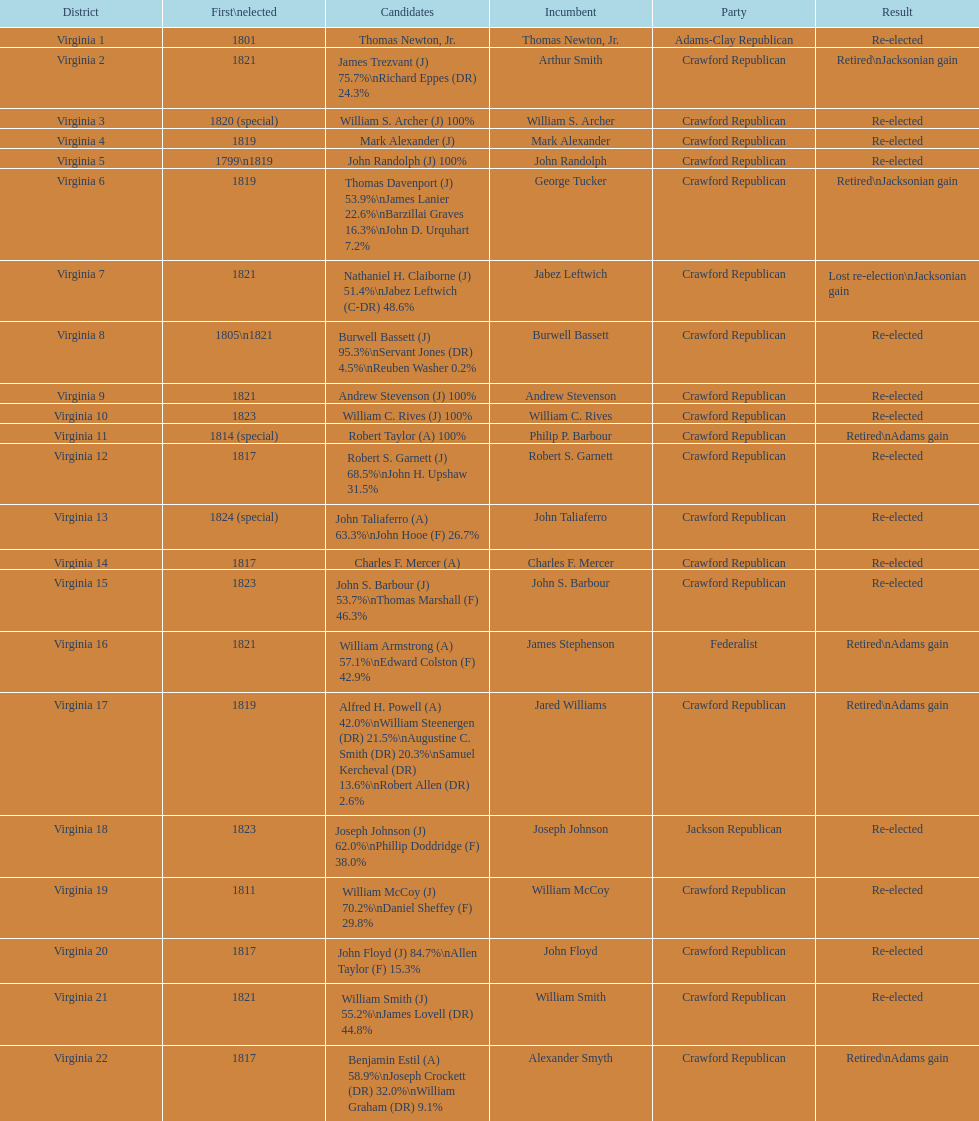Which jacksonian candidates got at least 76% of the vote in their races? Arthur Smith. 